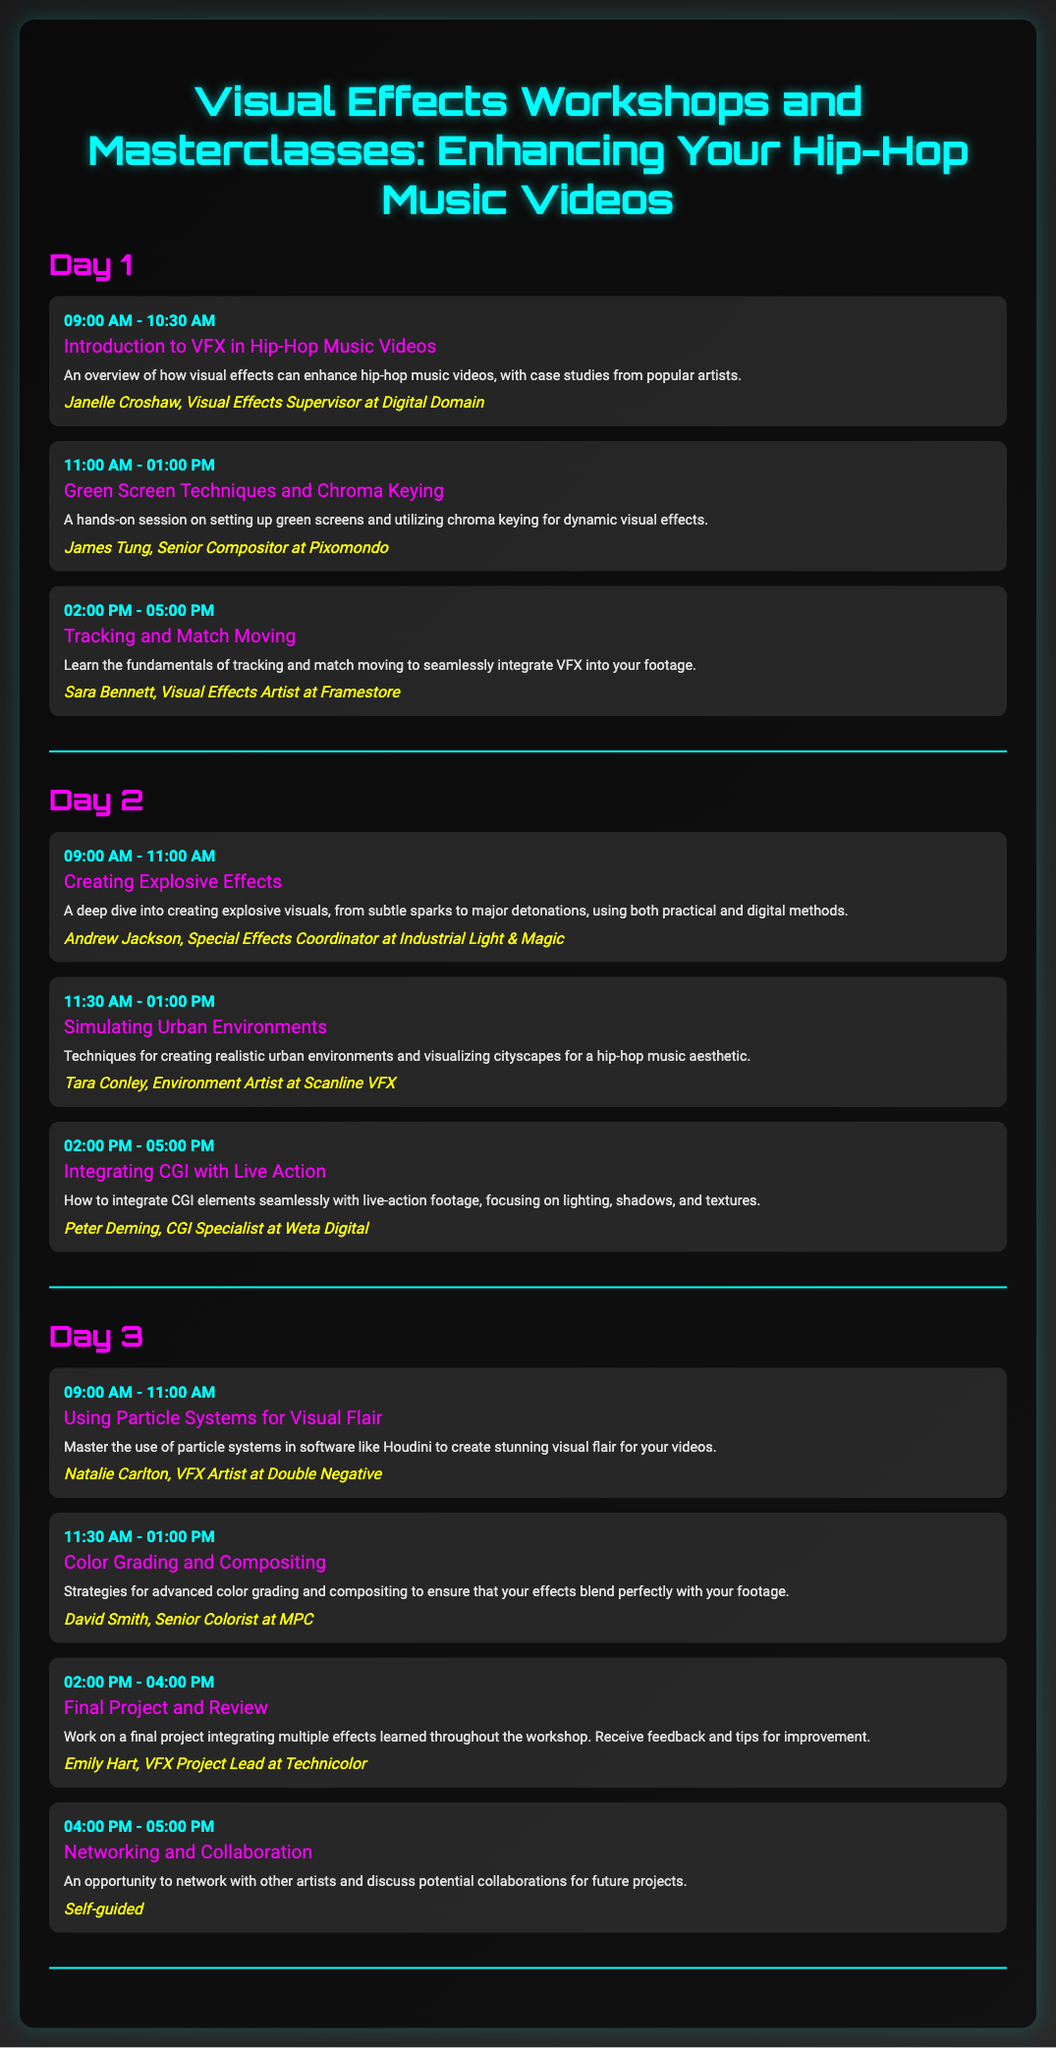What is the title of the first session on Day 1? The title of the first session is listed in the document under Day 1, detailing its content.
Answer: Introduction to VFX in Hip-Hop Music Videos Who is the instructor for the Green Screen Techniques session? The instructor's name is included in the details for the Green Screen Techniques session on Day 1.
Answer: James Tung What is the session time for Creating Explosive Effects? The session time can be found in the schedule for Day 2, specifying the timing of the session.
Answer: 09:00 AM - 11:00 AM How many sessions are scheduled for Day 3? This requires counting the number of session listings in Day 3 of the itinerary.
Answer: Four sessions What technique is covered in the session taught by Natalie Carlton? The session description specifies the focus of the techniques taught by Natalie Carlton.
Answer: Particle Systems What is the final activity of Day 3? The itinerary details the last session of Day 3, highlighting the closing activity.
Answer: Networking and Collaboration Which company does Peter Deming represent? The information about Peter Deming is mentioned within his session details concerning his employment.
Answer: Weta Digital What is the focus of the session titled Color Grading and Compositing? The description outlines the primary focus of the Color Grading and Compositing session.
Answer: Advanced color grading and compositing 